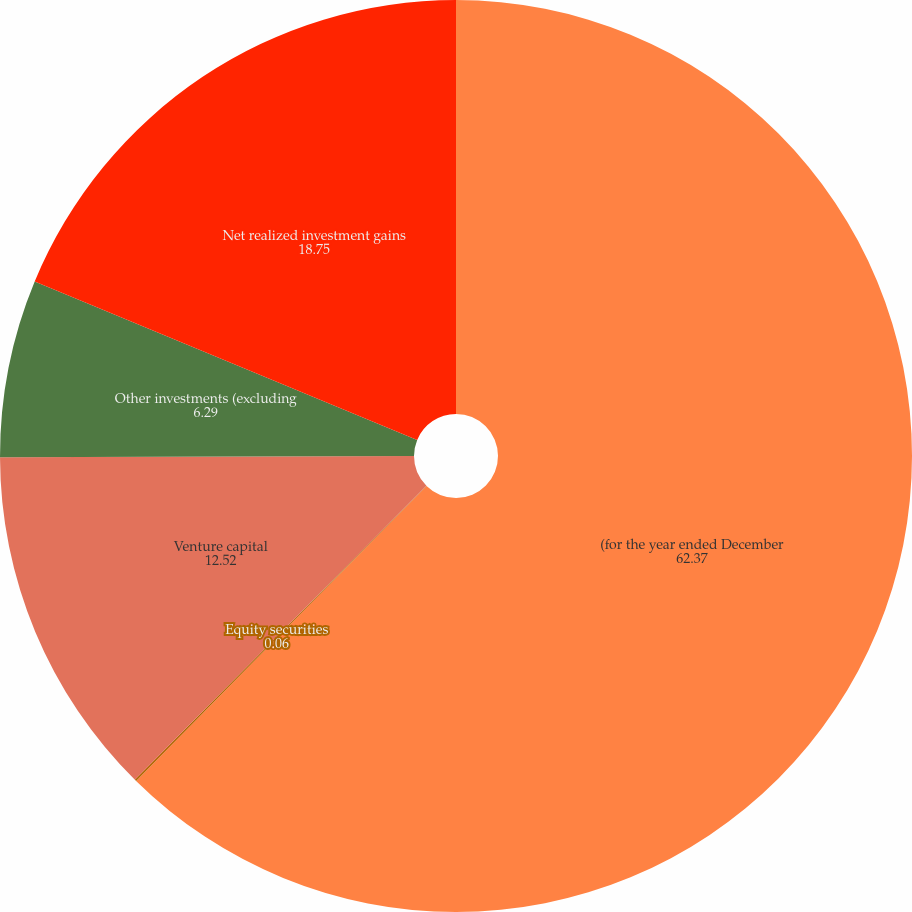Convert chart to OTSL. <chart><loc_0><loc_0><loc_500><loc_500><pie_chart><fcel>(for the year ended December<fcel>Equity securities<fcel>Venture capital<fcel>Other investments (excluding<fcel>Net realized investment gains<nl><fcel>62.37%<fcel>0.06%<fcel>12.52%<fcel>6.29%<fcel>18.75%<nl></chart> 